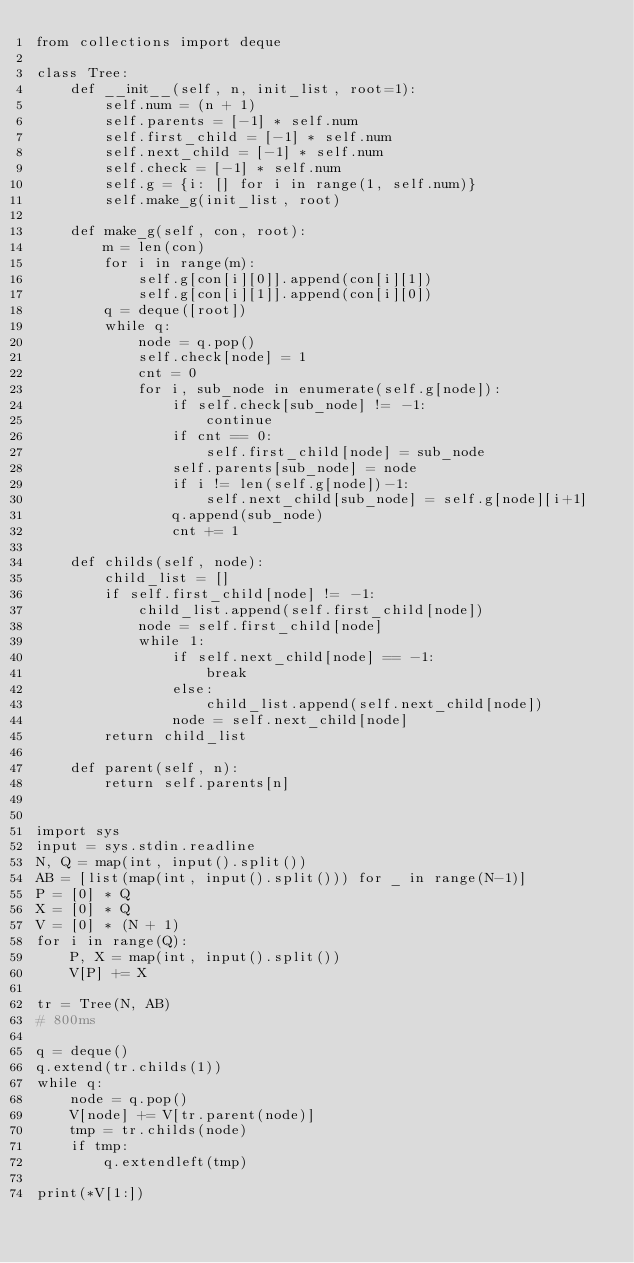Convert code to text. <code><loc_0><loc_0><loc_500><loc_500><_Python_>from collections import deque

class Tree:
    def __init__(self, n, init_list, root=1):
        self.num = (n + 1)
        self.parents = [-1] * self.num
        self.first_child = [-1] * self.num
        self.next_child = [-1] * self.num
        self.check = [-1] * self.num
        self.g = {i: [] for i in range(1, self.num)}
        self.make_g(init_list, root)

    def make_g(self, con, root):
        m = len(con)
        for i in range(m):
            self.g[con[i][0]].append(con[i][1])
            self.g[con[i][1]].append(con[i][0])
        q = deque([root])
        while q:
            node = q.pop()
            self.check[node] = 1
            cnt = 0
            for i, sub_node in enumerate(self.g[node]):
                if self.check[sub_node] != -1:
                    continue
                if cnt == 0:
                    self.first_child[node] = sub_node
                self.parents[sub_node] = node
                if i != len(self.g[node])-1:
                    self.next_child[sub_node] = self.g[node][i+1]
                q.append(sub_node)
                cnt += 1

    def childs(self, node):
        child_list = []
        if self.first_child[node] != -1:
            child_list.append(self.first_child[node])
            node = self.first_child[node]
            while 1:
                if self.next_child[node] == -1:
                    break
                else:
                    child_list.append(self.next_child[node])
                node = self.next_child[node]
        return child_list

    def parent(self, n):
        return self.parents[n]


import sys
input = sys.stdin.readline
N, Q = map(int, input().split())
AB = [list(map(int, input().split())) for _ in range(N-1)]
P = [0] * Q
X = [0] * Q
V = [0] * (N + 1)
for i in range(Q):
    P, X = map(int, input().split())
    V[P] += X

tr = Tree(N, AB)
# 800ms

q = deque()
q.extend(tr.childs(1))
while q:
    node = q.pop()
    V[node] += V[tr.parent(node)]
    tmp = tr.childs(node)
    if tmp:
        q.extendleft(tmp)

print(*V[1:])
</code> 